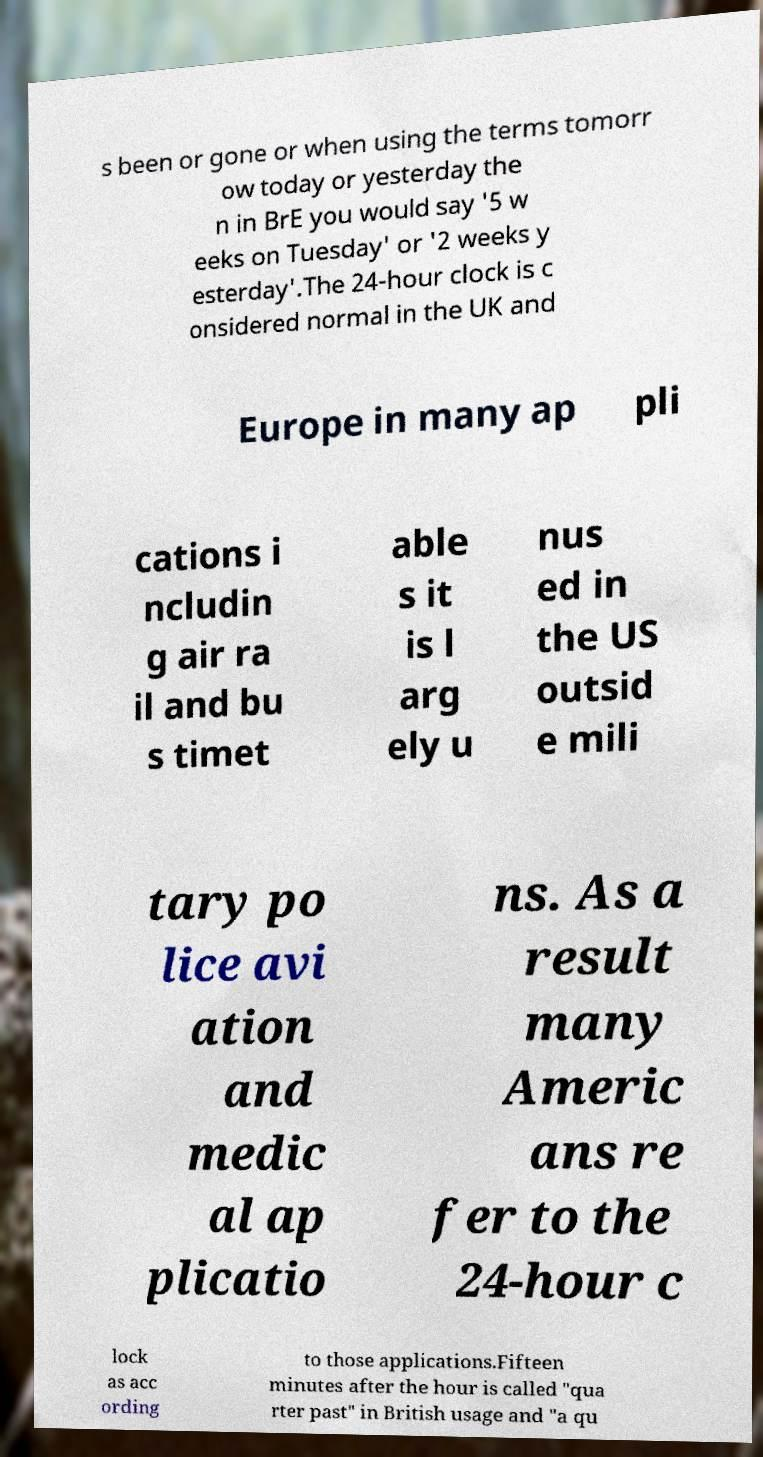Please read and relay the text visible in this image. What does it say? s been or gone or when using the terms tomorr ow today or yesterday the n in BrE you would say '5 w eeks on Tuesday' or '2 weeks y esterday'.The 24-hour clock is c onsidered normal in the UK and Europe in many ap pli cations i ncludin g air ra il and bu s timet able s it is l arg ely u nus ed in the US outsid e mili tary po lice avi ation and medic al ap plicatio ns. As a result many Americ ans re fer to the 24-hour c lock as acc ording to those applications.Fifteen minutes after the hour is called "qua rter past" in British usage and "a qu 